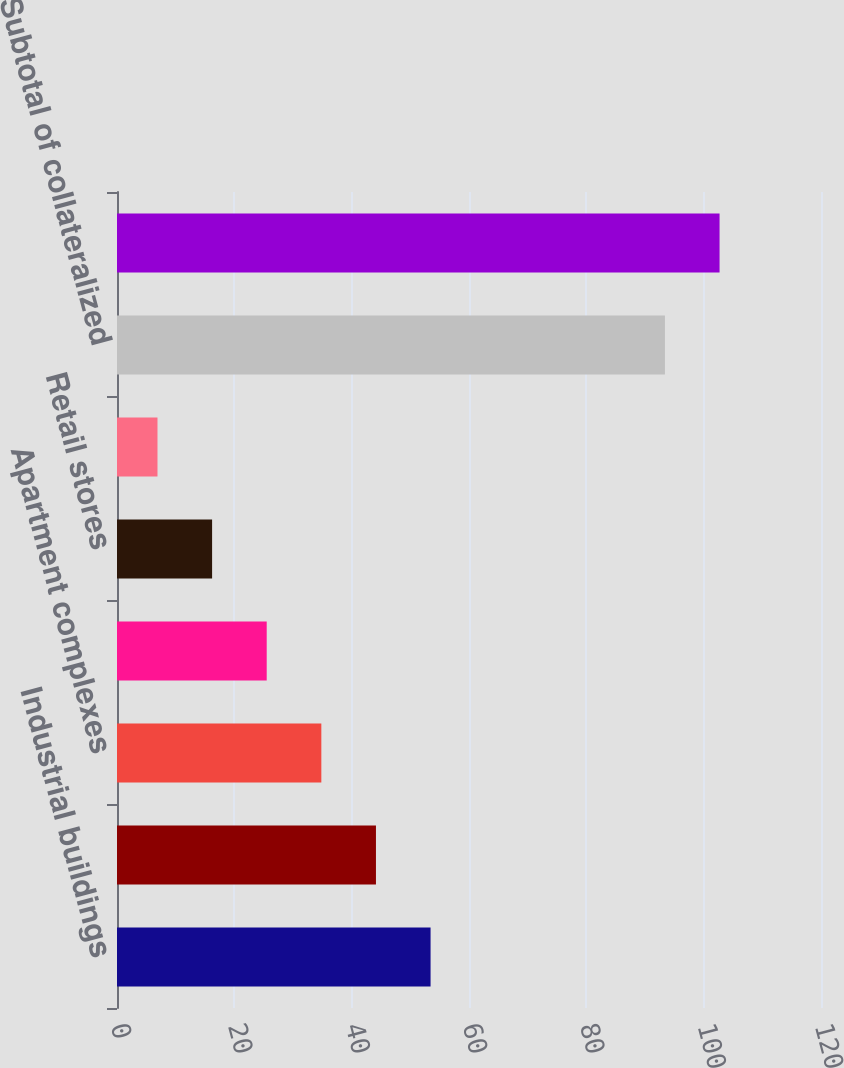Convert chart to OTSL. <chart><loc_0><loc_0><loc_500><loc_500><bar_chart><fcel>Industrial buildings<fcel>Office buildings<fcel>Apartment complexes<fcel>Other<fcel>Retail stores<fcel>Agricultural properties<fcel>Subtotal of collateralized<fcel>Total Commercial Loans<nl><fcel>53.45<fcel>44.14<fcel>34.83<fcel>25.52<fcel>16.21<fcel>6.9<fcel>93.4<fcel>102.71<nl></chart> 